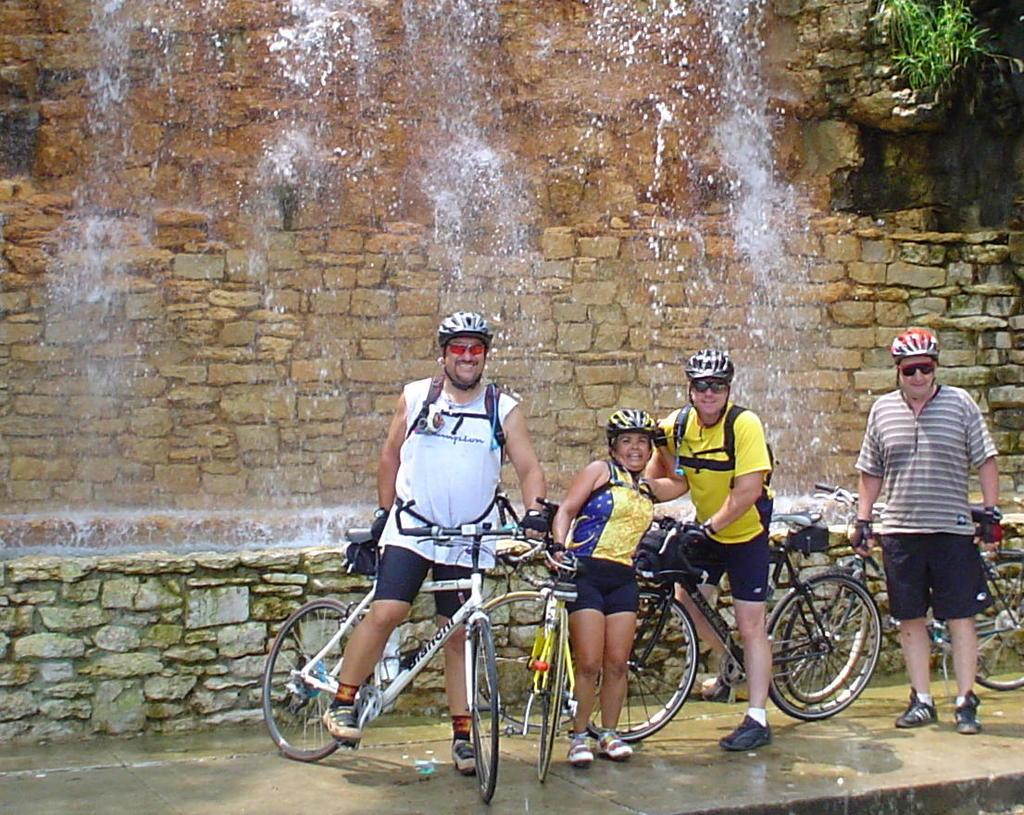How many people are in the image? There are four persons in the image. What are two of the persons doing in the image? Two of the persons are on a bicycle. What are the other two persons doing in the image? Two of the persons are standing on the floor. What can be seen in the background of the image? There is water visible in the background of the image. What type of business is being conducted by the women in the image? There are no women mentioned in the facts, and no business is being conducted in the image. 